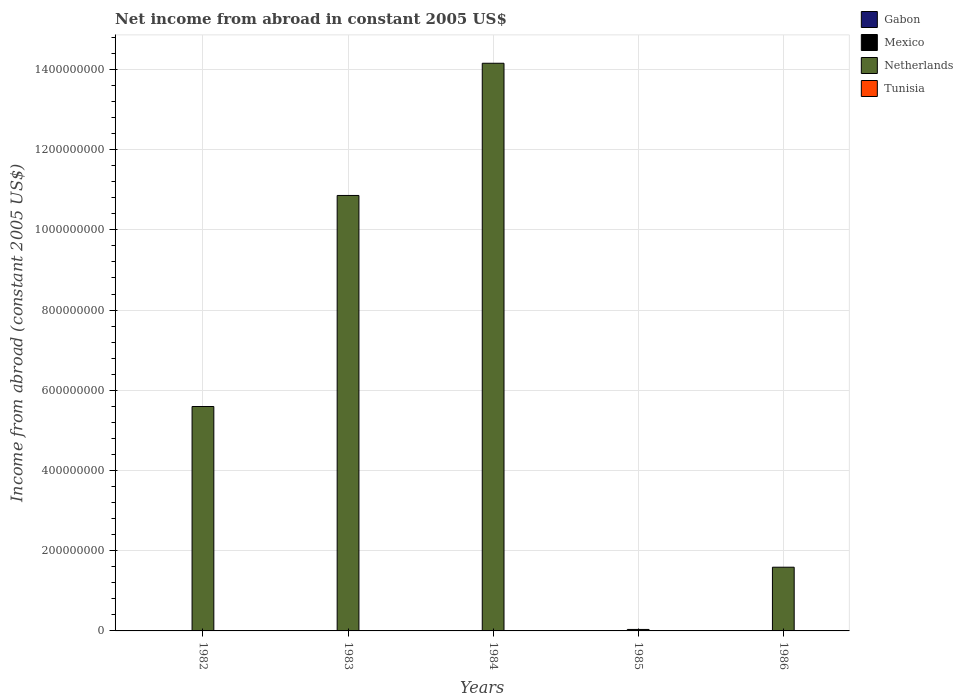How many different coloured bars are there?
Provide a short and direct response. 1. Are the number of bars per tick equal to the number of legend labels?
Offer a terse response. No. How many bars are there on the 5th tick from the left?
Offer a terse response. 1. What is the net income from abroad in Netherlands in 1984?
Provide a short and direct response. 1.42e+09. What is the total net income from abroad in Gabon in the graph?
Offer a very short reply. 0. What is the difference between the net income from abroad in Netherlands in 1983 and that in 1984?
Keep it short and to the point. -3.30e+08. What is the difference between the net income from abroad in Tunisia in 1982 and the net income from abroad in Netherlands in 1985?
Offer a terse response. -3.67e+06. What is the average net income from abroad in Netherlands per year?
Offer a very short reply. 6.45e+08. Is the net income from abroad in Netherlands in 1984 less than that in 1986?
Ensure brevity in your answer.  No. What is the difference between the highest and the lowest net income from abroad in Netherlands?
Your answer should be compact. 1.41e+09. In how many years, is the net income from abroad in Gabon greater than the average net income from abroad in Gabon taken over all years?
Offer a very short reply. 0. Is it the case that in every year, the sum of the net income from abroad in Tunisia and net income from abroad in Gabon is greater than the sum of net income from abroad in Mexico and net income from abroad in Netherlands?
Keep it short and to the point. No. Is it the case that in every year, the sum of the net income from abroad in Mexico and net income from abroad in Netherlands is greater than the net income from abroad in Tunisia?
Ensure brevity in your answer.  Yes. How many bars are there?
Provide a short and direct response. 5. Are all the bars in the graph horizontal?
Your answer should be compact. No. What is the difference between two consecutive major ticks on the Y-axis?
Give a very brief answer. 2.00e+08. Are the values on the major ticks of Y-axis written in scientific E-notation?
Offer a very short reply. No. Where does the legend appear in the graph?
Ensure brevity in your answer.  Top right. How are the legend labels stacked?
Offer a very short reply. Vertical. What is the title of the graph?
Your answer should be very brief. Net income from abroad in constant 2005 US$. What is the label or title of the X-axis?
Ensure brevity in your answer.  Years. What is the label or title of the Y-axis?
Offer a very short reply. Income from abroad (constant 2005 US$). What is the Income from abroad (constant 2005 US$) of Gabon in 1982?
Offer a terse response. 0. What is the Income from abroad (constant 2005 US$) of Mexico in 1982?
Give a very brief answer. 0. What is the Income from abroad (constant 2005 US$) of Netherlands in 1982?
Provide a short and direct response. 5.59e+08. What is the Income from abroad (constant 2005 US$) of Gabon in 1983?
Ensure brevity in your answer.  0. What is the Income from abroad (constant 2005 US$) of Mexico in 1983?
Provide a succinct answer. 0. What is the Income from abroad (constant 2005 US$) of Netherlands in 1983?
Give a very brief answer. 1.09e+09. What is the Income from abroad (constant 2005 US$) of Tunisia in 1983?
Offer a terse response. 0. What is the Income from abroad (constant 2005 US$) in Mexico in 1984?
Offer a very short reply. 0. What is the Income from abroad (constant 2005 US$) in Netherlands in 1984?
Ensure brevity in your answer.  1.42e+09. What is the Income from abroad (constant 2005 US$) of Tunisia in 1984?
Your answer should be very brief. 0. What is the Income from abroad (constant 2005 US$) of Gabon in 1985?
Provide a short and direct response. 0. What is the Income from abroad (constant 2005 US$) in Netherlands in 1985?
Offer a very short reply. 3.67e+06. What is the Income from abroad (constant 2005 US$) in Gabon in 1986?
Offer a terse response. 0. What is the Income from abroad (constant 2005 US$) of Mexico in 1986?
Your answer should be compact. 0. What is the Income from abroad (constant 2005 US$) of Netherlands in 1986?
Offer a very short reply. 1.59e+08. Across all years, what is the maximum Income from abroad (constant 2005 US$) of Netherlands?
Offer a very short reply. 1.42e+09. Across all years, what is the minimum Income from abroad (constant 2005 US$) in Netherlands?
Your answer should be very brief. 3.67e+06. What is the total Income from abroad (constant 2005 US$) of Mexico in the graph?
Provide a short and direct response. 0. What is the total Income from abroad (constant 2005 US$) of Netherlands in the graph?
Keep it short and to the point. 3.22e+09. What is the difference between the Income from abroad (constant 2005 US$) of Netherlands in 1982 and that in 1983?
Offer a terse response. -5.26e+08. What is the difference between the Income from abroad (constant 2005 US$) in Netherlands in 1982 and that in 1984?
Provide a succinct answer. -8.56e+08. What is the difference between the Income from abroad (constant 2005 US$) of Netherlands in 1982 and that in 1985?
Keep it short and to the point. 5.56e+08. What is the difference between the Income from abroad (constant 2005 US$) of Netherlands in 1982 and that in 1986?
Give a very brief answer. 4.01e+08. What is the difference between the Income from abroad (constant 2005 US$) of Netherlands in 1983 and that in 1984?
Provide a short and direct response. -3.30e+08. What is the difference between the Income from abroad (constant 2005 US$) in Netherlands in 1983 and that in 1985?
Your response must be concise. 1.08e+09. What is the difference between the Income from abroad (constant 2005 US$) in Netherlands in 1983 and that in 1986?
Your response must be concise. 9.27e+08. What is the difference between the Income from abroad (constant 2005 US$) of Netherlands in 1984 and that in 1985?
Provide a succinct answer. 1.41e+09. What is the difference between the Income from abroad (constant 2005 US$) in Netherlands in 1984 and that in 1986?
Your answer should be compact. 1.26e+09. What is the difference between the Income from abroad (constant 2005 US$) in Netherlands in 1985 and that in 1986?
Your answer should be compact. -1.55e+08. What is the average Income from abroad (constant 2005 US$) of Netherlands per year?
Keep it short and to the point. 6.45e+08. What is the average Income from abroad (constant 2005 US$) in Tunisia per year?
Ensure brevity in your answer.  0. What is the ratio of the Income from abroad (constant 2005 US$) of Netherlands in 1982 to that in 1983?
Offer a very short reply. 0.52. What is the ratio of the Income from abroad (constant 2005 US$) in Netherlands in 1982 to that in 1984?
Your response must be concise. 0.4. What is the ratio of the Income from abroad (constant 2005 US$) of Netherlands in 1982 to that in 1985?
Ensure brevity in your answer.  152.37. What is the ratio of the Income from abroad (constant 2005 US$) in Netherlands in 1982 to that in 1986?
Offer a terse response. 3.52. What is the ratio of the Income from abroad (constant 2005 US$) of Netherlands in 1983 to that in 1984?
Provide a short and direct response. 0.77. What is the ratio of the Income from abroad (constant 2005 US$) in Netherlands in 1983 to that in 1985?
Provide a short and direct response. 295.67. What is the ratio of the Income from abroad (constant 2005 US$) of Netherlands in 1983 to that in 1986?
Provide a short and direct response. 6.84. What is the ratio of the Income from abroad (constant 2005 US$) of Netherlands in 1984 to that in 1985?
Give a very brief answer. 385.44. What is the ratio of the Income from abroad (constant 2005 US$) in Netherlands in 1984 to that in 1986?
Offer a terse response. 8.91. What is the ratio of the Income from abroad (constant 2005 US$) of Netherlands in 1985 to that in 1986?
Make the answer very short. 0.02. What is the difference between the highest and the second highest Income from abroad (constant 2005 US$) in Netherlands?
Provide a short and direct response. 3.30e+08. What is the difference between the highest and the lowest Income from abroad (constant 2005 US$) of Netherlands?
Provide a short and direct response. 1.41e+09. 